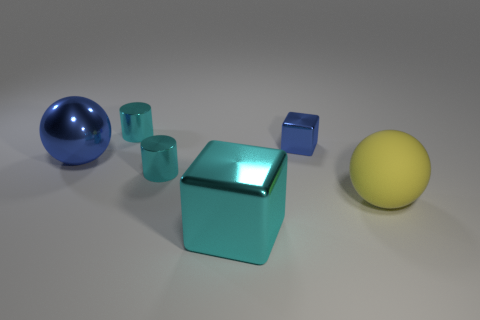Subtract all brown balls. Subtract all purple cylinders. How many balls are left? 2 Add 2 cyan cylinders. How many objects exist? 8 Subtract all cylinders. How many objects are left? 4 Subtract all cyan shiny cylinders. Subtract all big shiny balls. How many objects are left? 3 Add 3 yellow objects. How many yellow objects are left? 4 Add 3 big yellow matte balls. How many big yellow matte balls exist? 4 Subtract 0 red blocks. How many objects are left? 6 